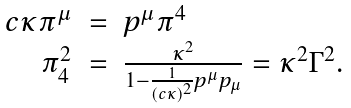<formula> <loc_0><loc_0><loc_500><loc_500>\begin{array} { r c l } c \kappa \pi ^ { \mu } & = & p ^ { \mu } \pi ^ { 4 } \\ \pi _ { 4 } ^ { 2 } & = & \frac { \kappa ^ { 2 } } { 1 - \frac { 1 } { ( c \kappa ) ^ { 2 } } p ^ { \mu } p _ { \mu } } = \kappa ^ { 2 } \Gamma ^ { 2 } . \end{array}</formula> 